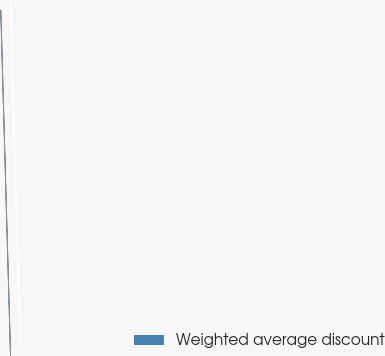Convert chart. <chart><loc_0><loc_0><loc_500><loc_500><pie_chart><fcel>Weighted average discount<nl><fcel>100.0%<nl></chart> 